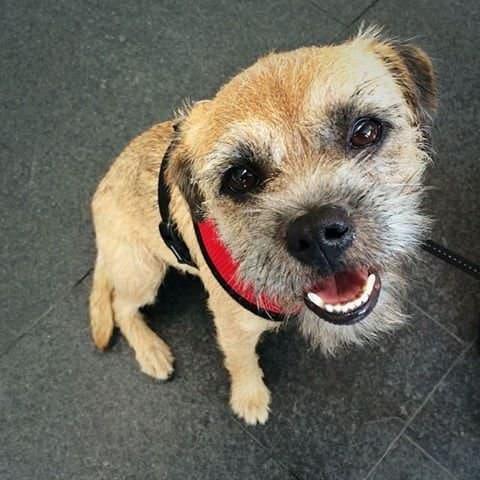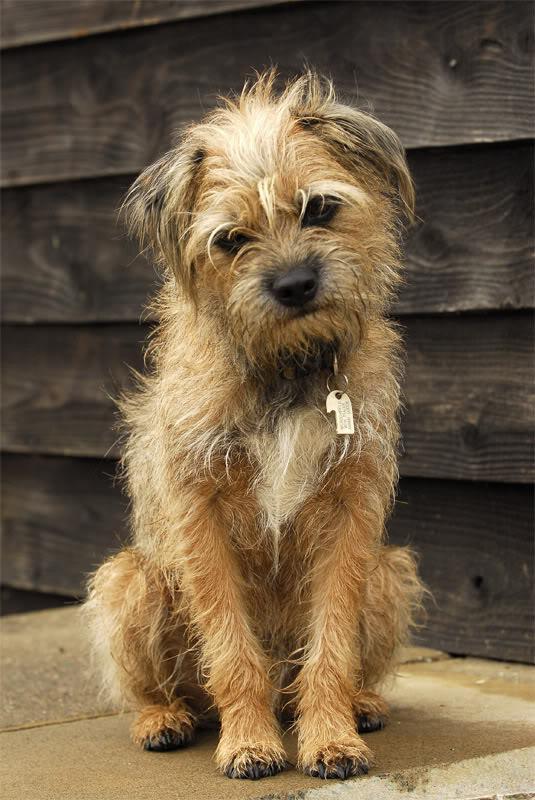The first image is the image on the left, the second image is the image on the right. Evaluate the accuracy of this statement regarding the images: "An image contains two dogs with their heads touching each other.". Is it true? Answer yes or no. No. 